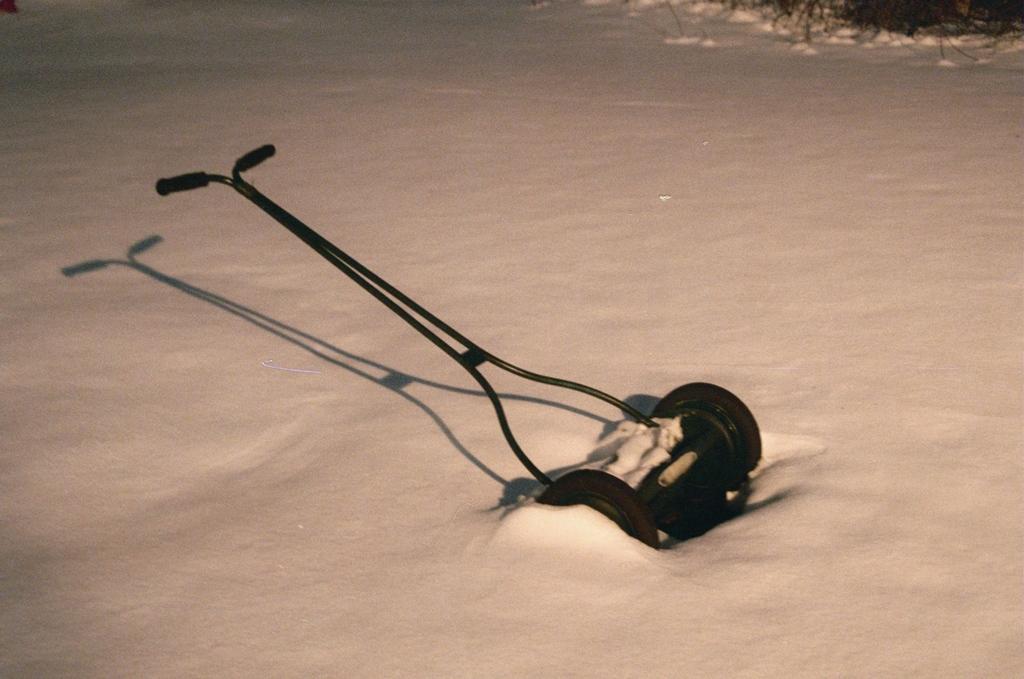How would you summarize this image in a sentence or two? In this image we can see a lawn mower placed on the ground. 